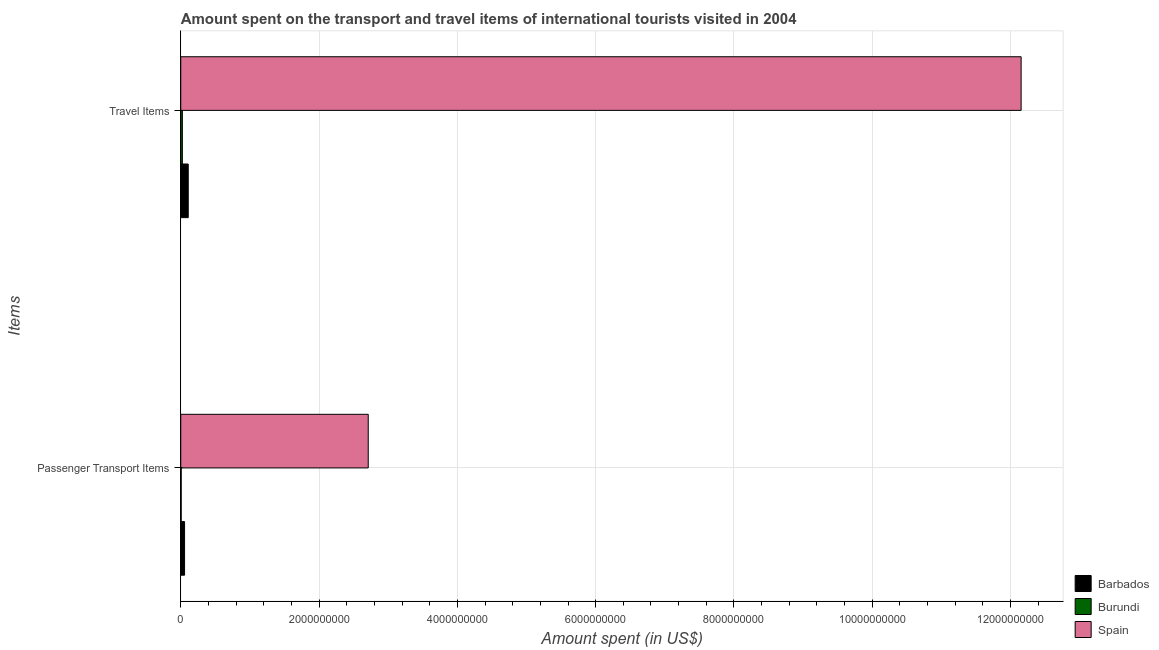How many groups of bars are there?
Offer a terse response. 2. Are the number of bars per tick equal to the number of legend labels?
Offer a terse response. Yes. Are the number of bars on each tick of the Y-axis equal?
Offer a terse response. Yes. How many bars are there on the 1st tick from the bottom?
Your answer should be very brief. 3. What is the label of the 1st group of bars from the top?
Your answer should be very brief. Travel Items. What is the amount spent on passenger transport items in Barbados?
Provide a short and direct response. 5.50e+07. Across all countries, what is the maximum amount spent on passenger transport items?
Offer a terse response. 2.71e+09. Across all countries, what is the minimum amount spent in travel items?
Offer a very short reply. 2.30e+07. In which country was the amount spent on passenger transport items minimum?
Keep it short and to the point. Burundi. What is the total amount spent in travel items in the graph?
Keep it short and to the point. 1.23e+1. What is the difference between the amount spent on passenger transport items in Barbados and that in Burundi?
Keep it short and to the point. 4.90e+07. What is the difference between the amount spent in travel items in Spain and the amount spent on passenger transport items in Barbados?
Your answer should be very brief. 1.21e+1. What is the average amount spent on passenger transport items per country?
Your response must be concise. 9.24e+08. What is the difference between the amount spent on passenger transport items and amount spent in travel items in Burundi?
Keep it short and to the point. -1.70e+07. In how many countries, is the amount spent on passenger transport items greater than 1200000000 US$?
Make the answer very short. 1. What is the ratio of the amount spent on passenger transport items in Barbados to that in Spain?
Your response must be concise. 0.02. What does the 1st bar from the top in Passenger Transport Items represents?
Give a very brief answer. Spain. What does the 3rd bar from the bottom in Passenger Transport Items represents?
Offer a very short reply. Spain. Are the values on the major ticks of X-axis written in scientific E-notation?
Offer a terse response. No. Does the graph contain any zero values?
Ensure brevity in your answer.  No. Where does the legend appear in the graph?
Ensure brevity in your answer.  Bottom right. How are the legend labels stacked?
Offer a very short reply. Vertical. What is the title of the graph?
Your answer should be compact. Amount spent on the transport and travel items of international tourists visited in 2004. Does "Tajikistan" appear as one of the legend labels in the graph?
Your response must be concise. No. What is the label or title of the X-axis?
Make the answer very short. Amount spent (in US$). What is the label or title of the Y-axis?
Provide a short and direct response. Items. What is the Amount spent (in US$) in Barbados in Passenger Transport Items?
Your answer should be compact. 5.50e+07. What is the Amount spent (in US$) in Burundi in Passenger Transport Items?
Give a very brief answer. 6.00e+06. What is the Amount spent (in US$) in Spain in Passenger Transport Items?
Provide a short and direct response. 2.71e+09. What is the Amount spent (in US$) of Barbados in Travel Items?
Make the answer very short. 1.08e+08. What is the Amount spent (in US$) in Burundi in Travel Items?
Your answer should be very brief. 2.30e+07. What is the Amount spent (in US$) in Spain in Travel Items?
Keep it short and to the point. 1.22e+1. Across all Items, what is the maximum Amount spent (in US$) in Barbados?
Your response must be concise. 1.08e+08. Across all Items, what is the maximum Amount spent (in US$) of Burundi?
Your response must be concise. 2.30e+07. Across all Items, what is the maximum Amount spent (in US$) in Spain?
Your answer should be compact. 1.22e+1. Across all Items, what is the minimum Amount spent (in US$) in Barbados?
Keep it short and to the point. 5.50e+07. Across all Items, what is the minimum Amount spent (in US$) of Spain?
Your answer should be compact. 2.71e+09. What is the total Amount spent (in US$) of Barbados in the graph?
Offer a terse response. 1.63e+08. What is the total Amount spent (in US$) in Burundi in the graph?
Offer a terse response. 2.90e+07. What is the total Amount spent (in US$) in Spain in the graph?
Ensure brevity in your answer.  1.49e+1. What is the difference between the Amount spent (in US$) in Barbados in Passenger Transport Items and that in Travel Items?
Your response must be concise. -5.30e+07. What is the difference between the Amount spent (in US$) of Burundi in Passenger Transport Items and that in Travel Items?
Ensure brevity in your answer.  -1.70e+07. What is the difference between the Amount spent (in US$) of Spain in Passenger Transport Items and that in Travel Items?
Provide a short and direct response. -9.44e+09. What is the difference between the Amount spent (in US$) of Barbados in Passenger Transport Items and the Amount spent (in US$) of Burundi in Travel Items?
Provide a short and direct response. 3.20e+07. What is the difference between the Amount spent (in US$) in Barbados in Passenger Transport Items and the Amount spent (in US$) in Spain in Travel Items?
Your response must be concise. -1.21e+1. What is the difference between the Amount spent (in US$) of Burundi in Passenger Transport Items and the Amount spent (in US$) of Spain in Travel Items?
Offer a terse response. -1.21e+1. What is the average Amount spent (in US$) of Barbados per Items?
Ensure brevity in your answer.  8.15e+07. What is the average Amount spent (in US$) of Burundi per Items?
Your answer should be compact. 1.45e+07. What is the average Amount spent (in US$) in Spain per Items?
Offer a terse response. 7.43e+09. What is the difference between the Amount spent (in US$) in Barbados and Amount spent (in US$) in Burundi in Passenger Transport Items?
Keep it short and to the point. 4.90e+07. What is the difference between the Amount spent (in US$) of Barbados and Amount spent (in US$) of Spain in Passenger Transport Items?
Your answer should be compact. -2.66e+09. What is the difference between the Amount spent (in US$) of Burundi and Amount spent (in US$) of Spain in Passenger Transport Items?
Provide a succinct answer. -2.70e+09. What is the difference between the Amount spent (in US$) of Barbados and Amount spent (in US$) of Burundi in Travel Items?
Offer a terse response. 8.50e+07. What is the difference between the Amount spent (in US$) of Barbados and Amount spent (in US$) of Spain in Travel Items?
Provide a succinct answer. -1.20e+1. What is the difference between the Amount spent (in US$) in Burundi and Amount spent (in US$) in Spain in Travel Items?
Keep it short and to the point. -1.21e+1. What is the ratio of the Amount spent (in US$) of Barbados in Passenger Transport Items to that in Travel Items?
Your answer should be very brief. 0.51. What is the ratio of the Amount spent (in US$) of Burundi in Passenger Transport Items to that in Travel Items?
Your answer should be very brief. 0.26. What is the ratio of the Amount spent (in US$) of Spain in Passenger Transport Items to that in Travel Items?
Provide a succinct answer. 0.22. What is the difference between the highest and the second highest Amount spent (in US$) in Barbados?
Provide a succinct answer. 5.30e+07. What is the difference between the highest and the second highest Amount spent (in US$) of Burundi?
Offer a very short reply. 1.70e+07. What is the difference between the highest and the second highest Amount spent (in US$) of Spain?
Keep it short and to the point. 9.44e+09. What is the difference between the highest and the lowest Amount spent (in US$) of Barbados?
Give a very brief answer. 5.30e+07. What is the difference between the highest and the lowest Amount spent (in US$) in Burundi?
Offer a very short reply. 1.70e+07. What is the difference between the highest and the lowest Amount spent (in US$) in Spain?
Give a very brief answer. 9.44e+09. 